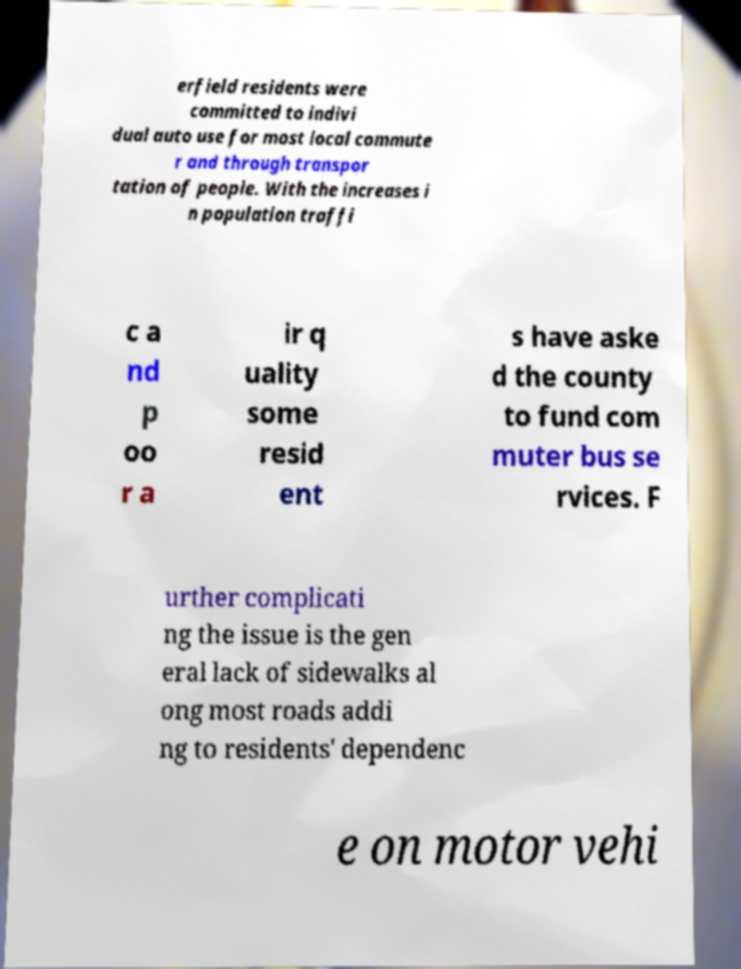What messages or text are displayed in this image? I need them in a readable, typed format. erfield residents were committed to indivi dual auto use for most local commute r and through transpor tation of people. With the increases i n population traffi c a nd p oo r a ir q uality some resid ent s have aske d the county to fund com muter bus se rvices. F urther complicati ng the issue is the gen eral lack of sidewalks al ong most roads addi ng to residents' dependenc e on motor vehi 